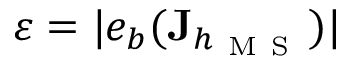<formula> <loc_0><loc_0><loc_500><loc_500>\varepsilon = | e _ { b } ( J _ { h _ { M S } } ) |</formula> 